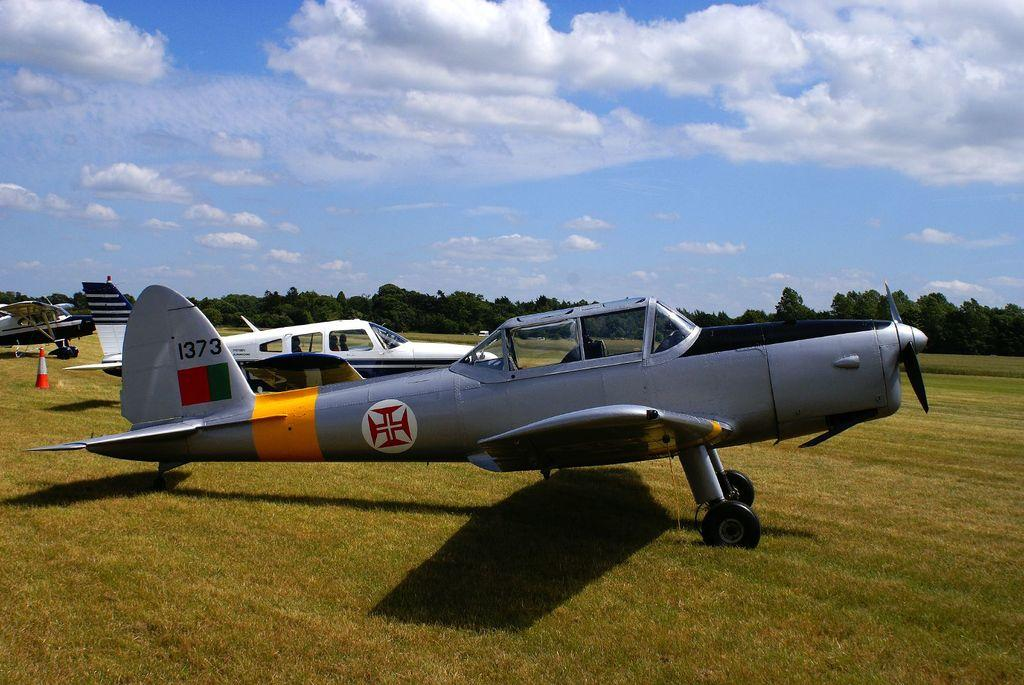<image>
Share a concise interpretation of the image provided. A small gray airplane has the number 1373 on the tail. 